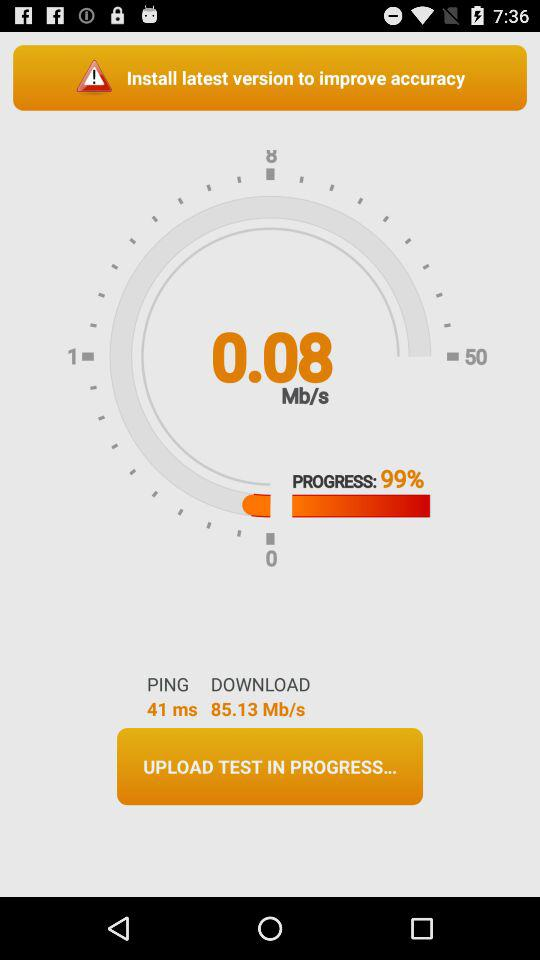What's the download speed? The download speed is 85.13 Mb/s. 